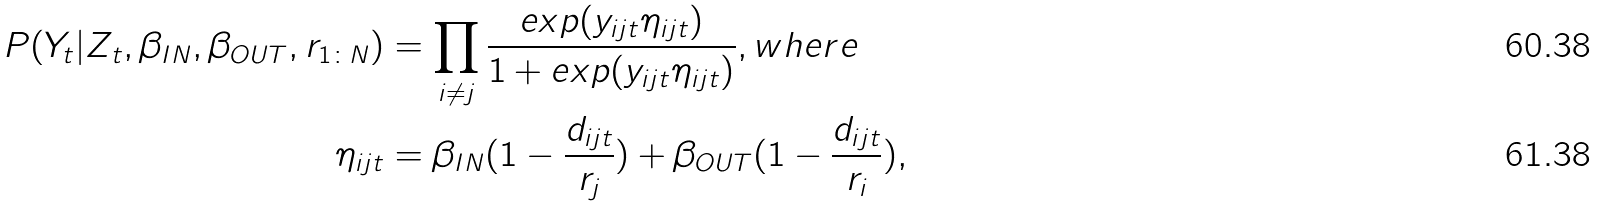<formula> <loc_0><loc_0><loc_500><loc_500>P ( { Y } _ { t } | { Z } _ { t } , \beta _ { I N } , \beta _ { O U T } , r _ { 1 \colon N } ) & = \prod _ { i \neq j } \frac { e x p ( y _ { i j t } \eta _ { i j t } ) } { 1 + e x p ( y _ { i j t } \eta _ { i j t } ) } , w h e r e \\ \eta _ { i j t } & = \beta _ { I N } ( 1 - \frac { d _ { i j t } } { r _ { j } } ) + \beta _ { O U T } ( 1 - \frac { d _ { i j t } } { r _ { i } } ) ,</formula> 